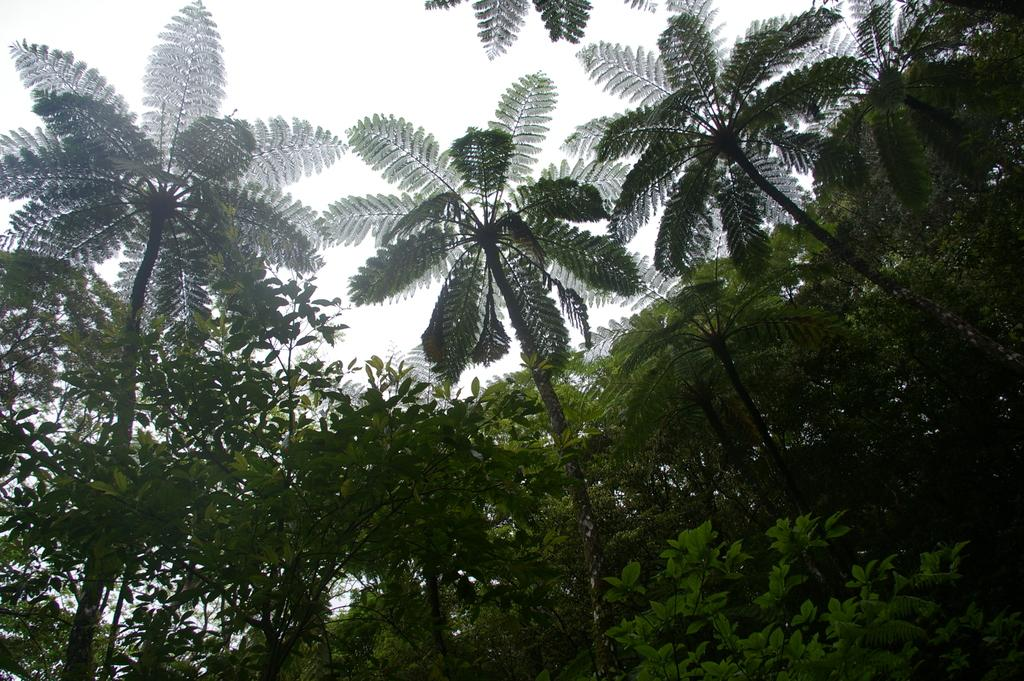What type of vegetation is visible in the image? There are trees in front of the image. What is visible at the top of the image? The sky is visible at the top of the image. What is the weight of the flesh visible in the image? There is no flesh present in the image; it only features trees and the sky. 